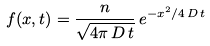<formula> <loc_0><loc_0><loc_500><loc_500>f ( x , t ) = \frac { n } { \sqrt { 4 \pi \, D \, t } } \, e ^ { - x ^ { 2 } / 4 \, D \, t }</formula> 